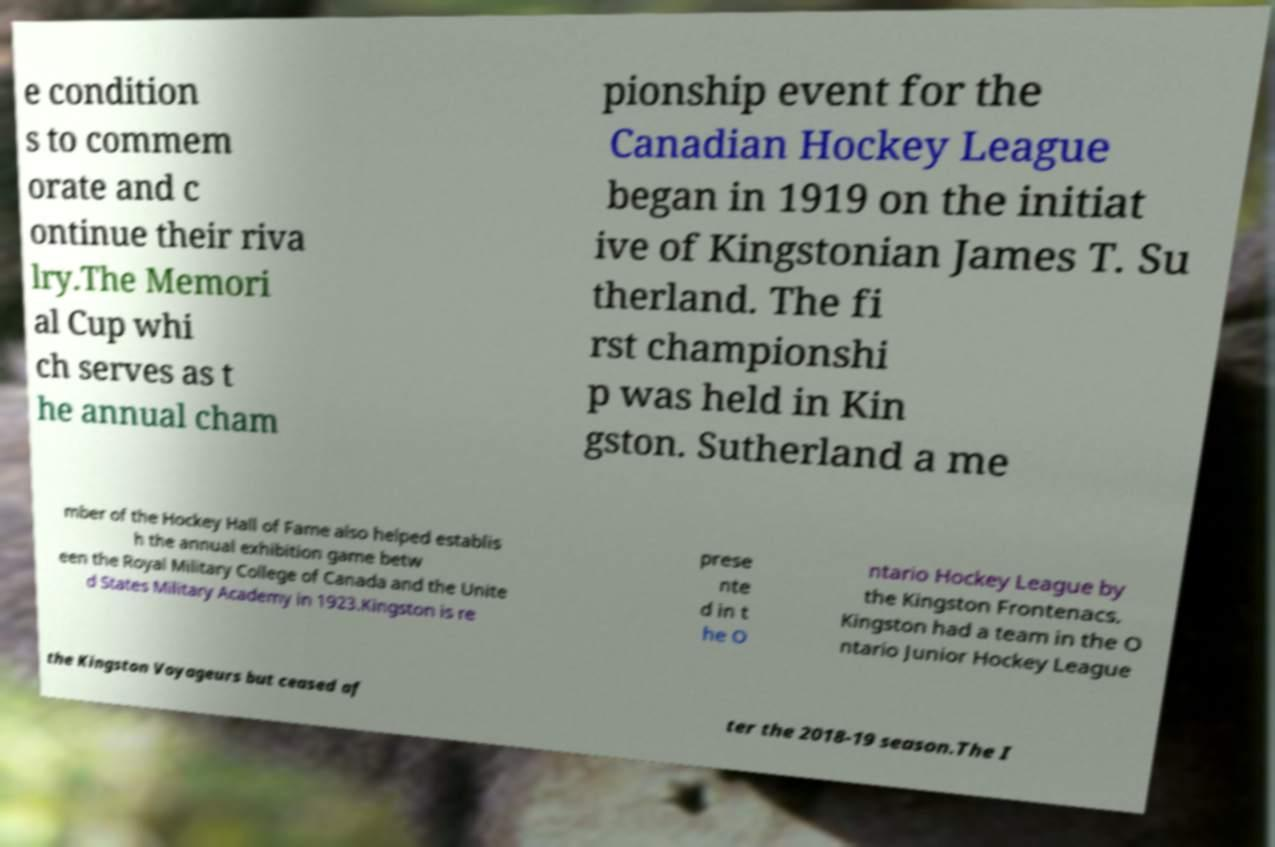There's text embedded in this image that I need extracted. Can you transcribe it verbatim? e condition s to commem orate and c ontinue their riva lry.The Memori al Cup whi ch serves as t he annual cham pionship event for the Canadian Hockey League began in 1919 on the initiat ive of Kingstonian James T. Su therland. The fi rst championshi p was held in Kin gston. Sutherland a me mber of the Hockey Hall of Fame also helped establis h the annual exhibition game betw een the Royal Military College of Canada and the Unite d States Military Academy in 1923.Kingston is re prese nte d in t he O ntario Hockey League by the Kingston Frontenacs. Kingston had a team in the O ntario Junior Hockey League the Kingston Voyageurs but ceased af ter the 2018-19 season.The I 